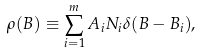<formula> <loc_0><loc_0><loc_500><loc_500>\rho ( B ) \equiv \sum _ { i = 1 } ^ { m } A _ { i } N _ { i } \delta ( B - B _ { i } ) ,</formula> 